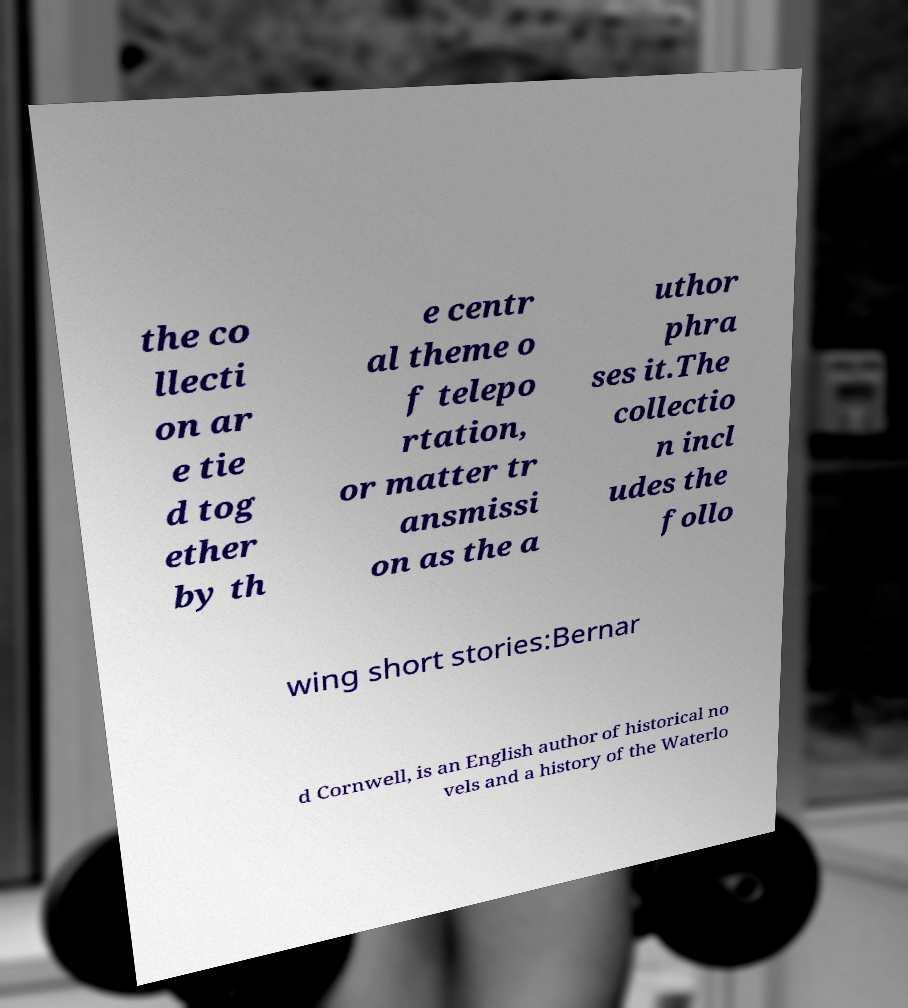I need the written content from this picture converted into text. Can you do that? the co llecti on ar e tie d tog ether by th e centr al theme o f telepo rtation, or matter tr ansmissi on as the a uthor phra ses it.The collectio n incl udes the follo wing short stories:Bernar d Cornwell, is an English author of historical no vels and a history of the Waterlo 